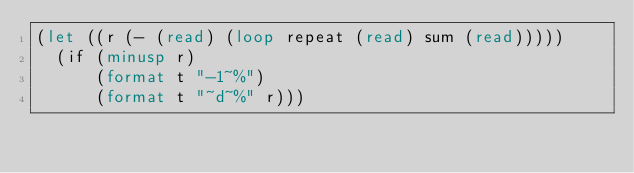Convert code to text. <code><loc_0><loc_0><loc_500><loc_500><_Lisp_>(let ((r (- (read) (loop repeat (read) sum (read)))))
  (if (minusp r)
      (format t "-1~%")
      (format t "~d~%" r)))</code> 